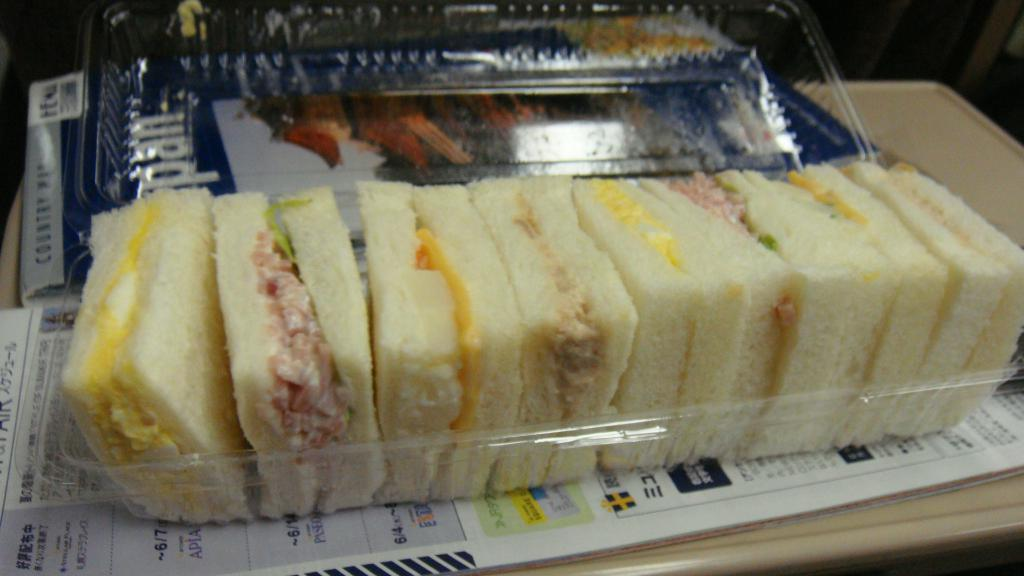What type of food is visible in the image? There are sandwich breads in the image. How are the sandwich breads stored? The sandwich breads are in a transparent box. Where is the transparent box located? The transparent box is on a table. What other item can be seen on the table? There is a menu card on the table. How does the stomach feel about the sandwich breads in the image? The image does not show or imply any emotions or feelings from a stomach, as it is an inanimate object. 